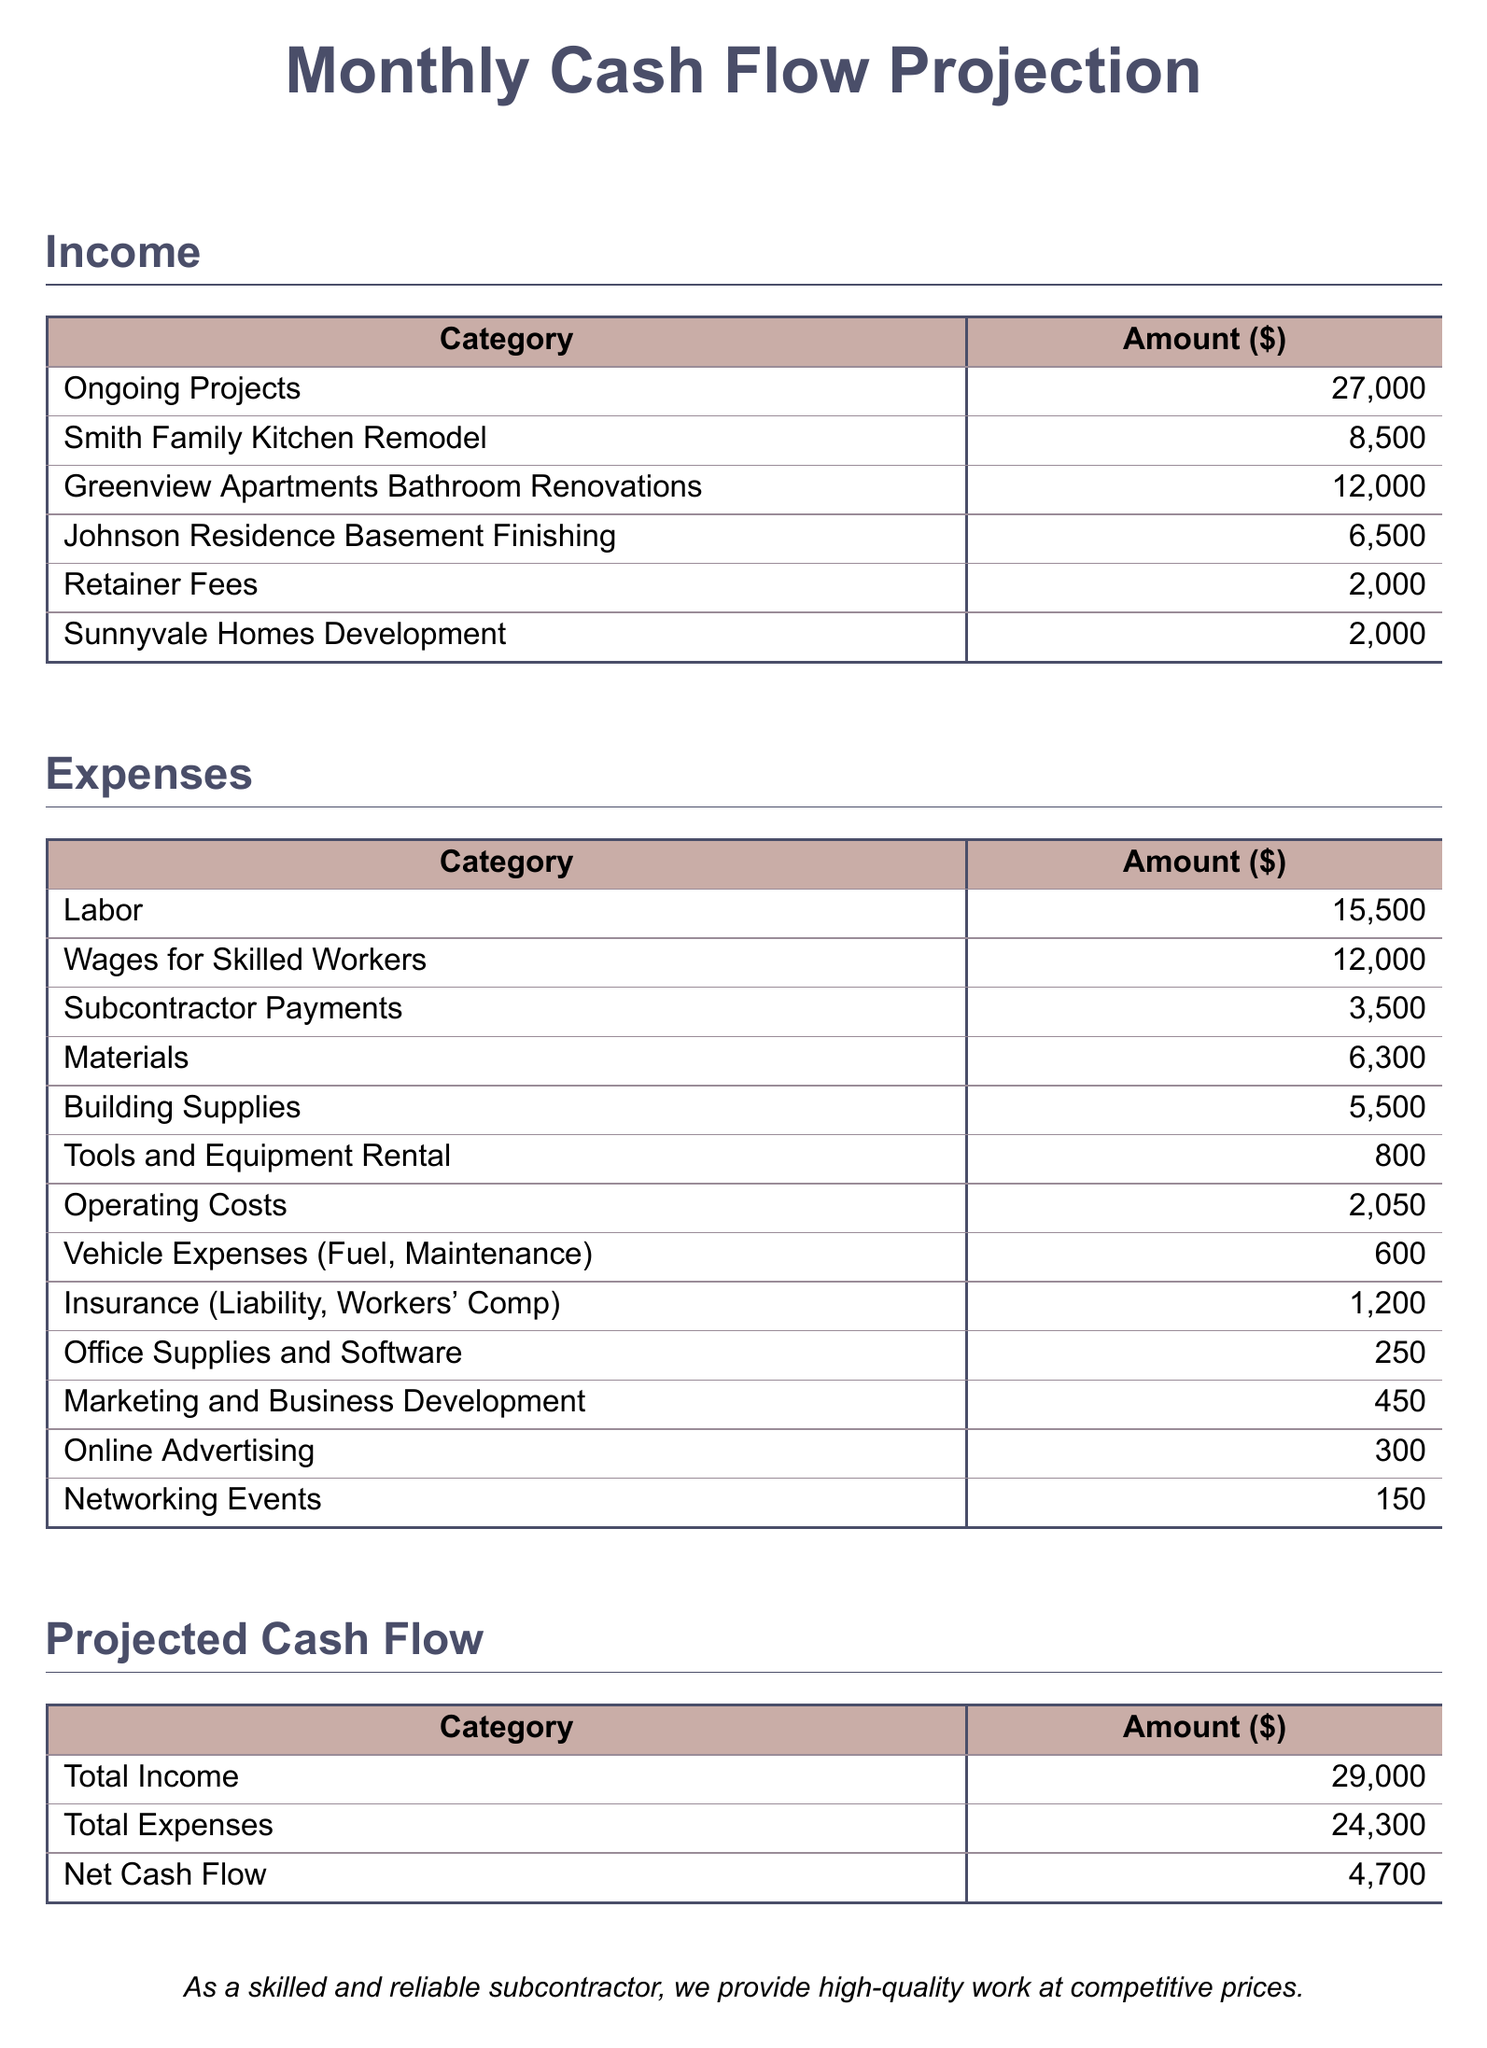What is the total income from ongoing projects? The total income from ongoing projects is explicitly listed in the document under "Income" as a single value.
Answer: 27,000 How much is allocated for labor expenses? The labor expenses are categorized in the document, providing a clear amount specifically for labor costs.
Answer: 15,500 What is the amount for marketing and business development? The document lists marketing and business development costs, detailing the specific amount allocated for this category.
Answer: 450 What is the net cash flow projection? The net cash flow is calculated as the difference between total income and total expenses, provided in the summary at the end.
Answer: 4,700 Which ongoing project has the highest income? The ongoing projects are listed with their respective income amounts; the answer can be derived from the documented figures.
Answer: Greenview Apartments Bathroom Renovations What is the total amount for materials? The expenses section of the document includes a category for materials, giving the specific amount spent.
Answer: 6,300 What are the total expenses listed in the document? The total expenses amount is clearly stated in the projected cash flow section, summarizing all the costs incurred.
Answer: 24,300 What is the amount for subcontractor payments? The expenses document mentions a specific category dedicated to subcontractor payments, providing its corresponding amount.
Answer: 3,500 What is the amount spent on insurance? The insurance costs are clearly detailed in the expenses section, allowing direct retrieval of this value.
Answer: 1,200 